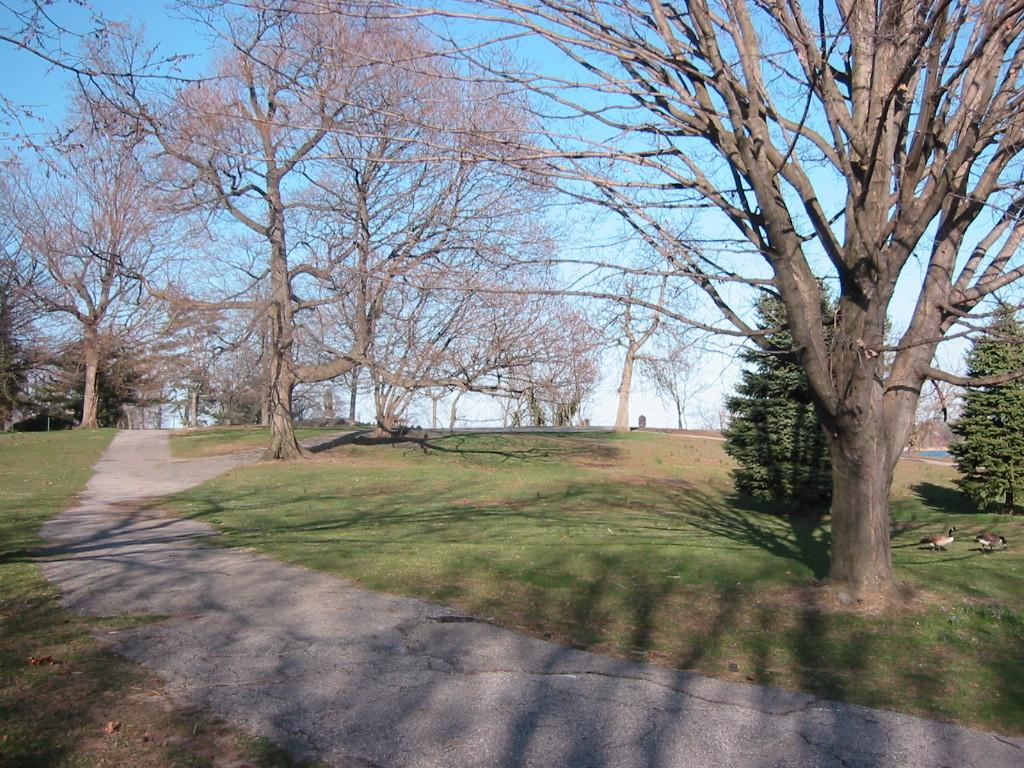What is the main feature of the image? There is a road in the image. What else can be seen in the image besides the road? There are many trees and grasses on the right side of the image. Are there any living creatures visible in the image? Yes, there are birds visible in the image. What can be seen in the background of the image? The sky is visible in the background of the image. Can you see any goldfish swimming in the image? No, there are no goldfish present in the image. What type of liquid can be seen flowing through the image? There is no liquid visible in the image; it primarily features a road, trees, grasses, birds, and the sky. 